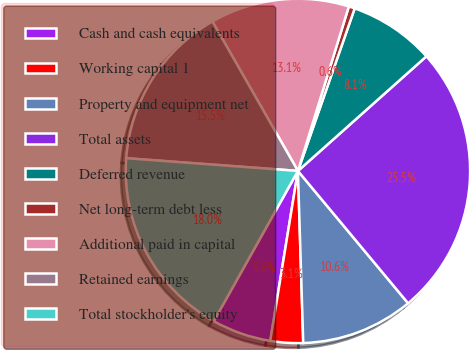<chart> <loc_0><loc_0><loc_500><loc_500><pie_chart><fcel>Cash and cash equivalents<fcel>Working capital 1<fcel>Property and equipment net<fcel>Total assets<fcel>Deferred revenue<fcel>Net long-term debt less<fcel>Additional paid in capital<fcel>Retained earnings<fcel>Total stockholder's equity<nl><fcel>5.56%<fcel>3.06%<fcel>10.56%<fcel>25.54%<fcel>8.06%<fcel>0.57%<fcel>13.05%<fcel>15.55%<fcel>18.05%<nl></chart> 